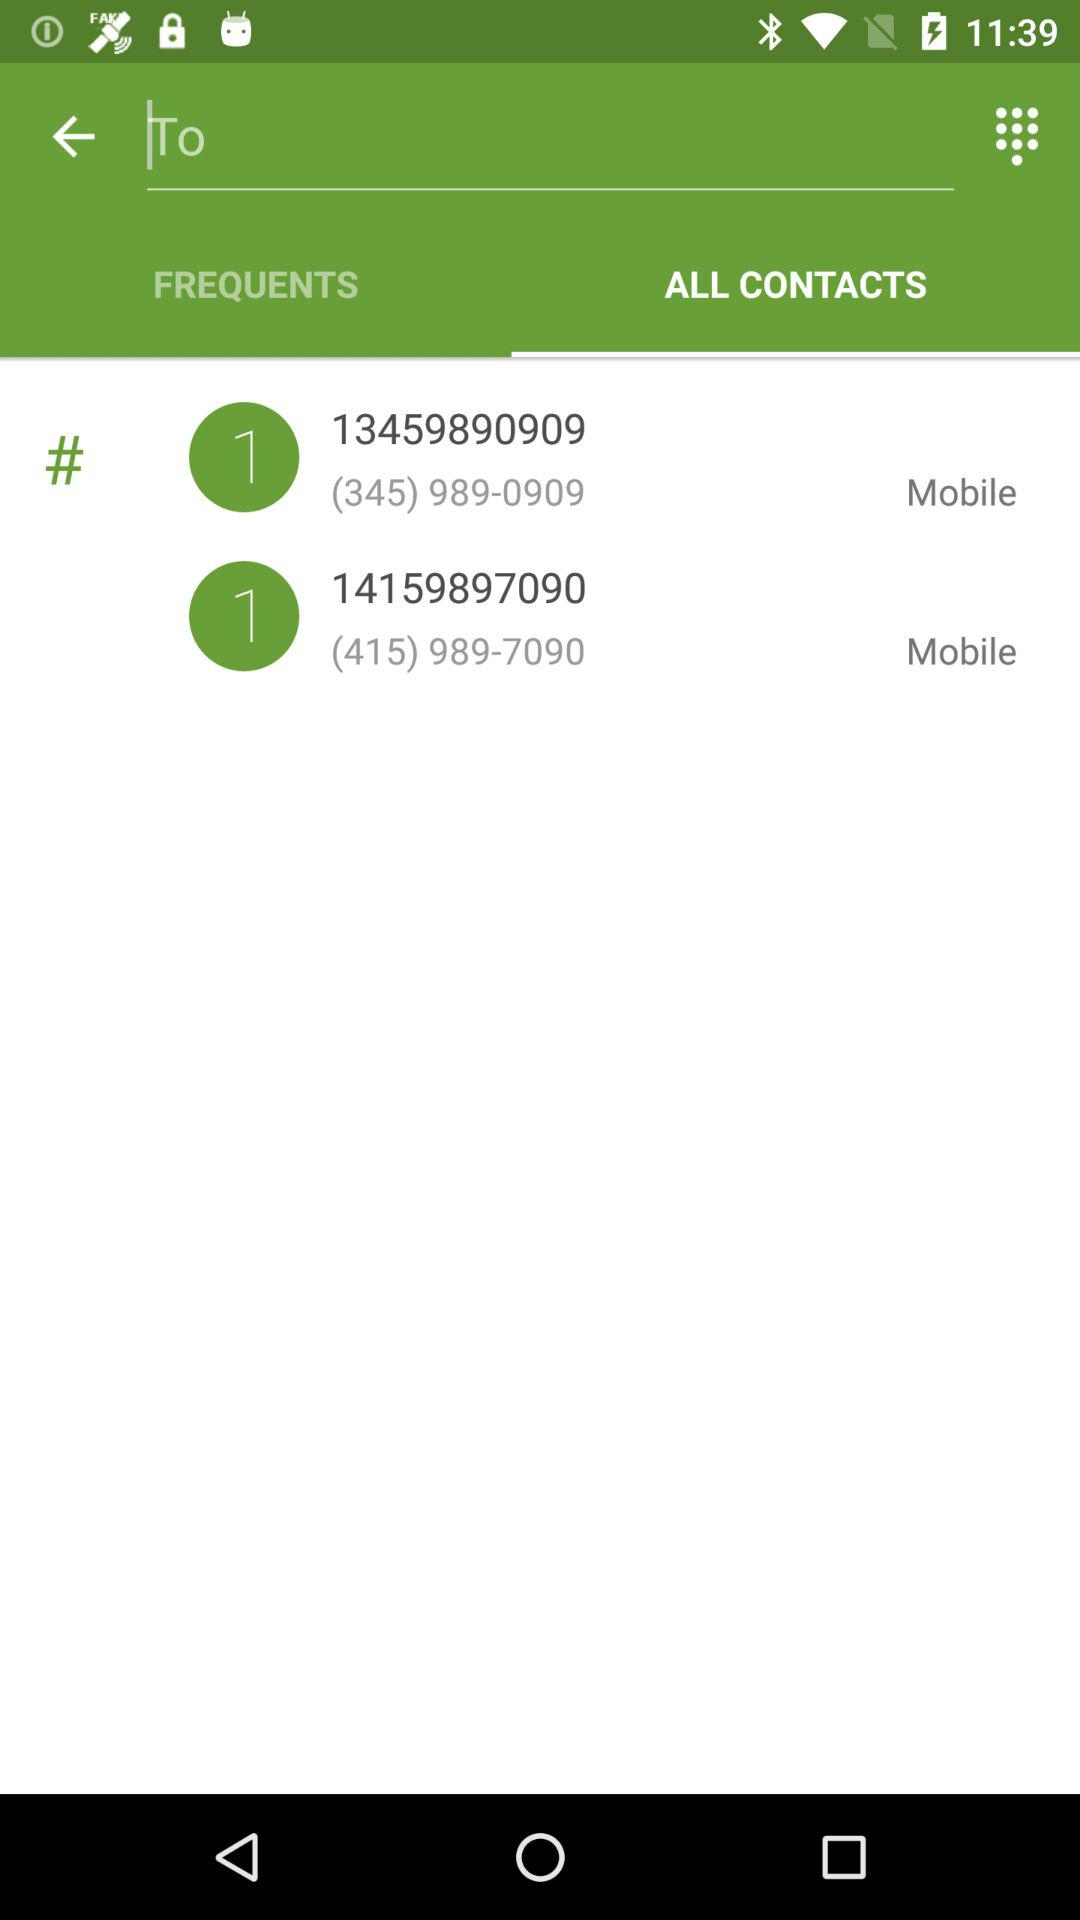What are the phone numbers I have in my contacts? The phone numbers are 13459890909 and 14159897090. 